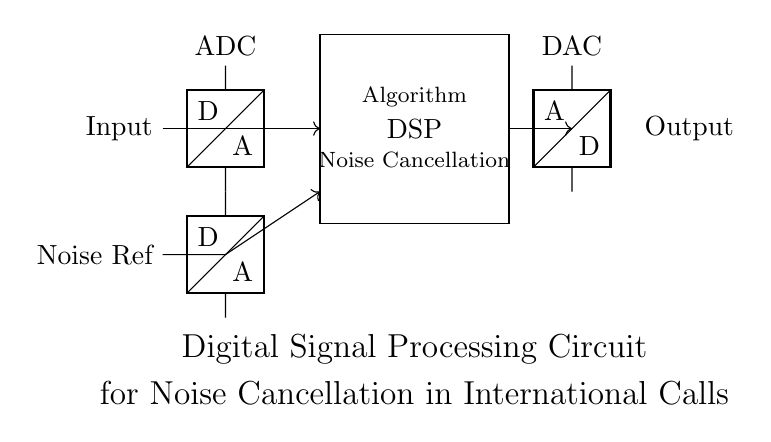What is the input of this circuit? The input is labeled as "Input" on the left side of the circuit diagram, indicating where the signal enters the circuit.
Answer: Input What type of component is the first element after the input? The first element after the input is an ADC (Analog to Digital Converter), which is depicted in the circuit symbol shown.
Answer: ADC What is the function of the DSP block? The DSP block is labeled "Noise Cancellation" which indicates that its purpose is to process the signal to reduce noise during the call.
Answer: Noise Cancellation How many ADCs are present in this circuit? There are two ADCs visible in the circuit; the first one converts the input signal, and the second converts the noise reference signal.
Answer: Two What is transferred through the DAC component? The DAC (Digital to Analog Converter) takes the processed digital signal from the DSP and converts it back into an analog signal for output.
Answer: Output signal What does the signal flow direction indicate? The arrows in the circuit diagram indicate the direction of signal flow from input through the DSP to output, showing how the circuit processes the signals step-by-step.
Answer: Signal flow direction What role does the noise reference play in this circuit? The noise reference provides a comparison signal to effectively detect and cancel out noise in the primary input signal at the DSP stage.
Answer: Noise detection 